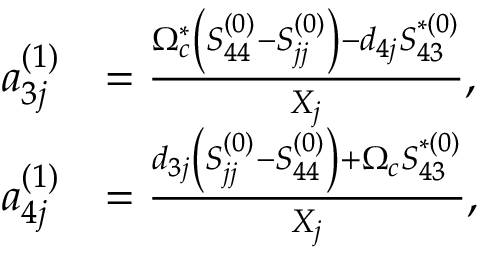<formula> <loc_0><loc_0><loc_500><loc_500>\begin{array} { r l } { a _ { 3 j } ^ { ( 1 ) } } & { = \frac { \Omega _ { c } ^ { \ast } \left ( S _ { 4 4 } ^ { ( 0 ) } - S _ { j j } ^ { ( 0 ) } \right ) - d _ { 4 j } S _ { 4 3 } ^ { \ast ( 0 ) } } { X _ { j } } , } \\ { a _ { 4 j } ^ { ( 1 ) } } & { = \frac { d _ { 3 j } \left ( S _ { j j } ^ { ( 0 ) } - S _ { 4 4 } ^ { ( 0 ) } \right ) + \Omega _ { c } S _ { 4 3 } ^ { \ast ( 0 ) } } { X _ { j } } , } \end{array}</formula> 